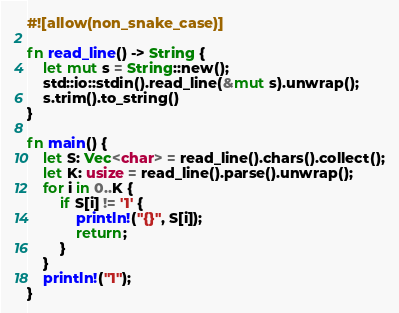<code> <loc_0><loc_0><loc_500><loc_500><_Rust_>#![allow(non_snake_case)]

fn read_line() -> String {
    let mut s = String::new();
    std::io::stdin().read_line(&mut s).unwrap();
    s.trim().to_string()
}

fn main() {
    let S: Vec<char> = read_line().chars().collect();
    let K: usize = read_line().parse().unwrap();
    for i in 0..K {
        if S[i] != '1' {
            println!("{}", S[i]);
            return;
        }
    }
    println!("1");
}
</code> 